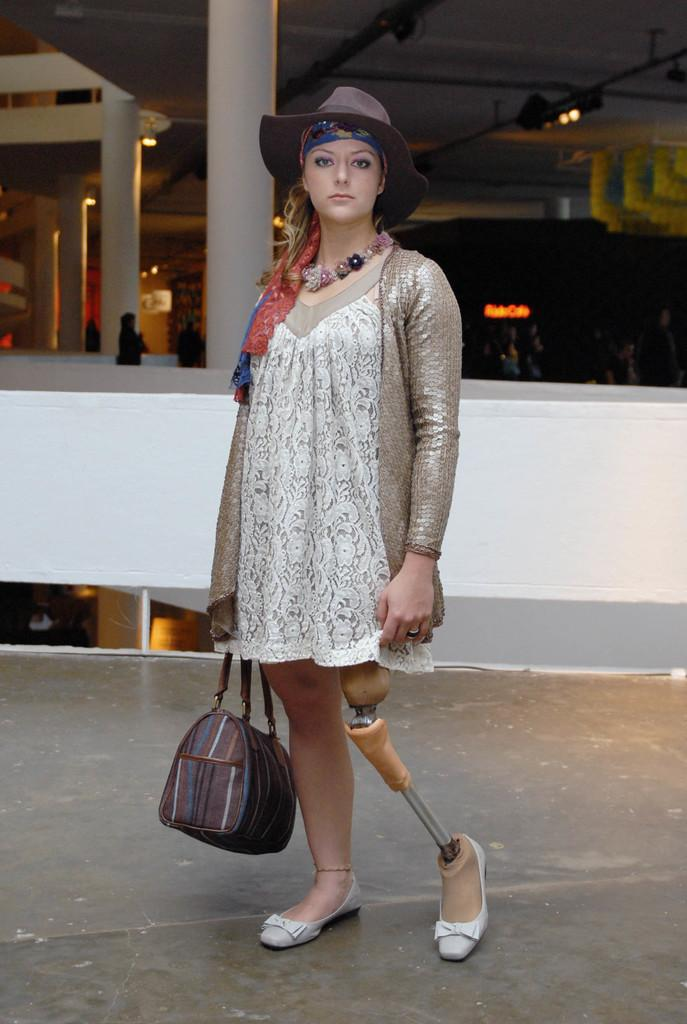Who is the main subject in the picture? There is a woman in the picture. What is the woman holding in her right hand? The woman is holding a bag in her right hand. Can you describe any unique features of the woman? The woman has an artificial limb on her left leg. What is the texture of the fold in the beggar's cloak in the image? There is no beggar or fold in a cloak present in the image. 